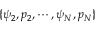Convert formula to latex. <formula><loc_0><loc_0><loc_500><loc_500>\{ \psi _ { 2 } , p _ { 2 } , \cdots , \psi _ { N } , p _ { N } \}</formula> 